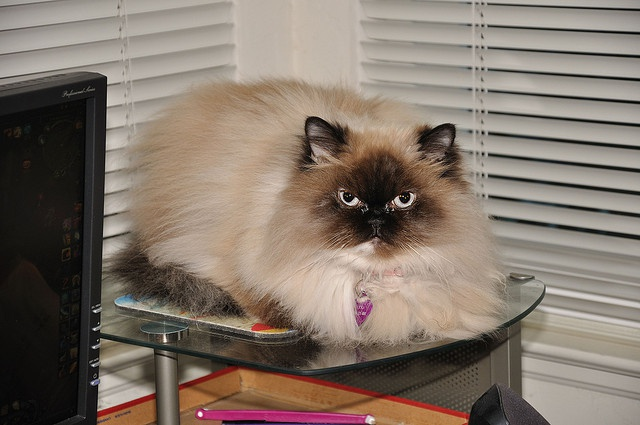Describe the objects in this image and their specific colors. I can see cat in gray and tan tones, tv in gray, black, and darkgray tones, and dining table in gray and black tones in this image. 